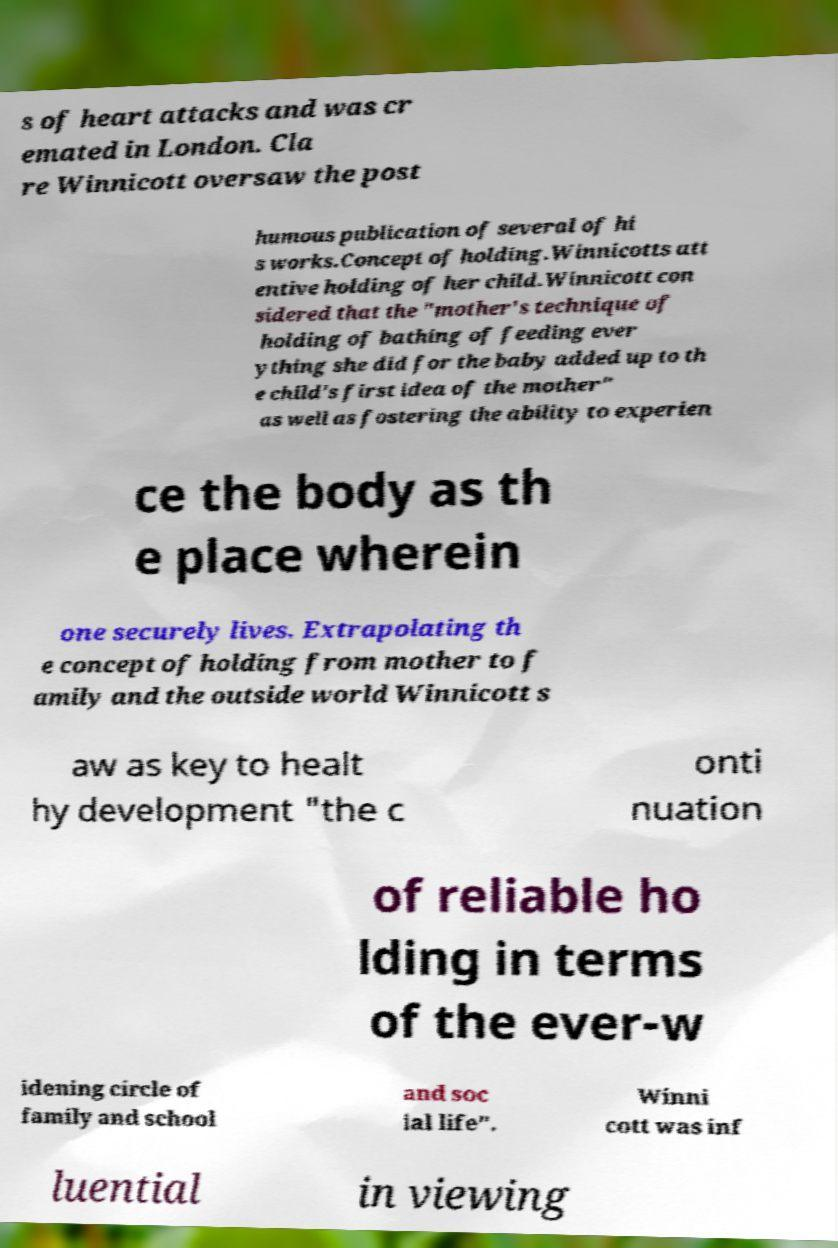Could you extract and type out the text from this image? s of heart attacks and was cr emated in London. Cla re Winnicott oversaw the post humous publication of several of hi s works.Concept of holding.Winnicotts att entive holding of her child.Winnicott con sidered that the "mother's technique of holding of bathing of feeding ever ything she did for the baby added up to th e child's first idea of the mother" as well as fostering the ability to experien ce the body as th e place wherein one securely lives. Extrapolating th e concept of holding from mother to f amily and the outside world Winnicott s aw as key to healt hy development "the c onti nuation of reliable ho lding in terms of the ever-w idening circle of family and school and soc ial life". Winni cott was inf luential in viewing 